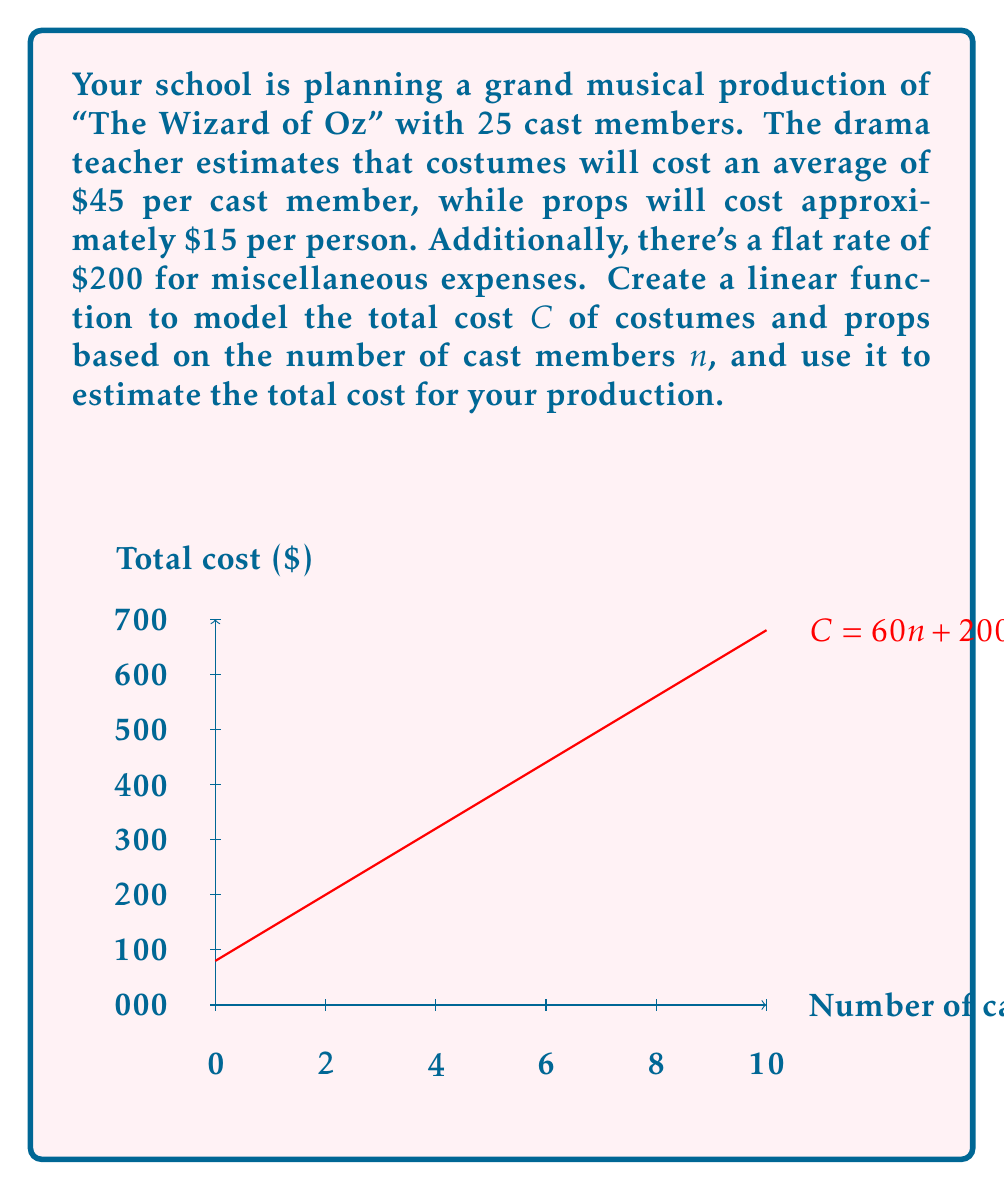What is the answer to this math problem? Let's approach this step-by-step:

1) First, we need to identify the components of our linear function:
   - Cost per cast member for costumes: $45
   - Cost per cast member for props: $15
   - Total cost per cast member: $45 + $15 = $60
   - Flat rate for miscellaneous expenses: $200

2) We can now create our linear function:
   $C = 60n + 200$
   Where $C$ is the total cost and $n$ is the number of cast members.

3) To break this down:
   - $60n$ represents the variable cost that changes with the number of cast members
   - $200$ is the fixed cost that remains constant regardless of cast size

4) Now, let's plug in our given number of cast members (25) to estimate the total cost:

   $C = 60(25) + 200$
   $C = 1500 + 200$
   $C = 1700$

5) Therefore, the estimated total cost for costumes and props for your production of "The Wizard of Oz" with 25 cast members is $1700.

The graph provided visualizes this linear relationship, showing how the total cost increases as the number of cast members increases.
Answer: $1700 